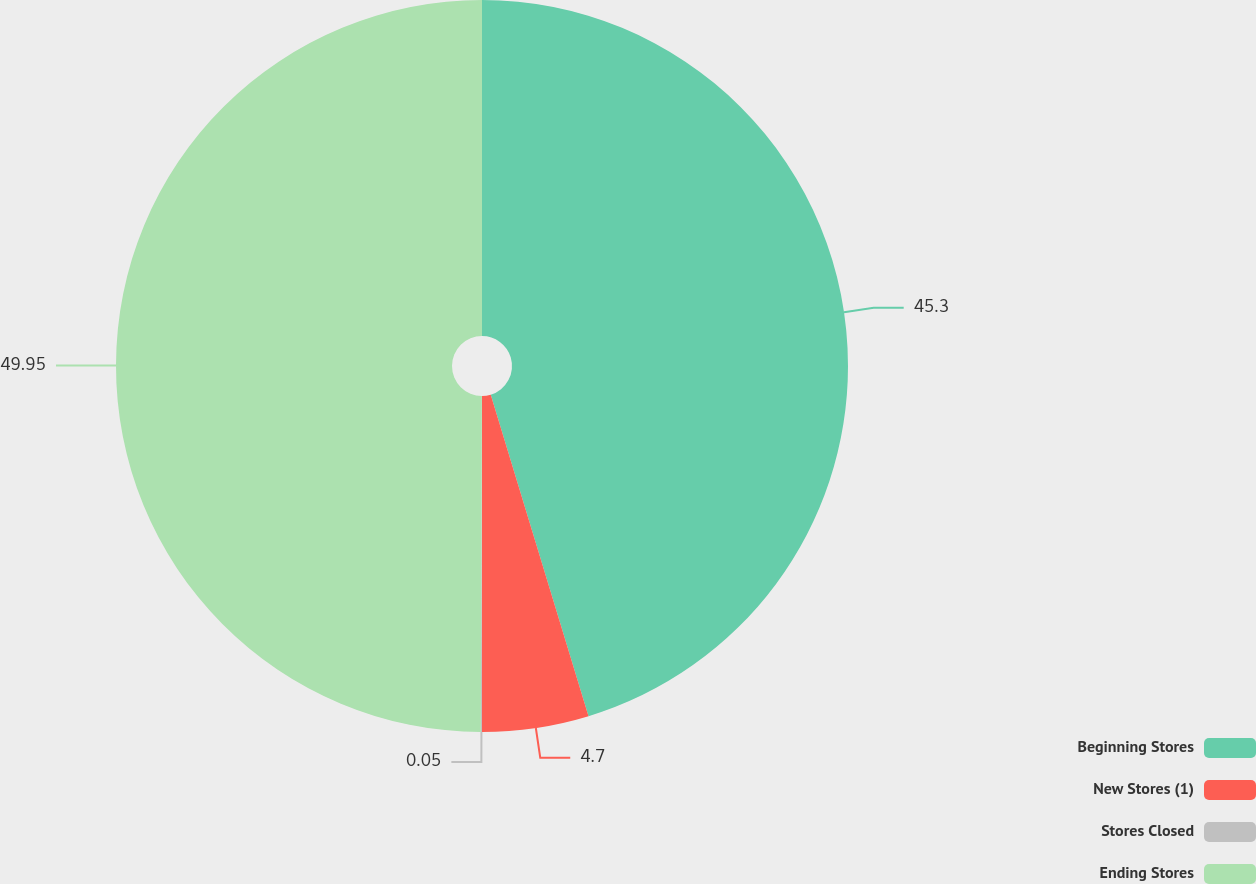Convert chart to OTSL. <chart><loc_0><loc_0><loc_500><loc_500><pie_chart><fcel>Beginning Stores<fcel>New Stores (1)<fcel>Stores Closed<fcel>Ending Stores<nl><fcel>45.3%<fcel>4.7%<fcel>0.05%<fcel>49.95%<nl></chart> 